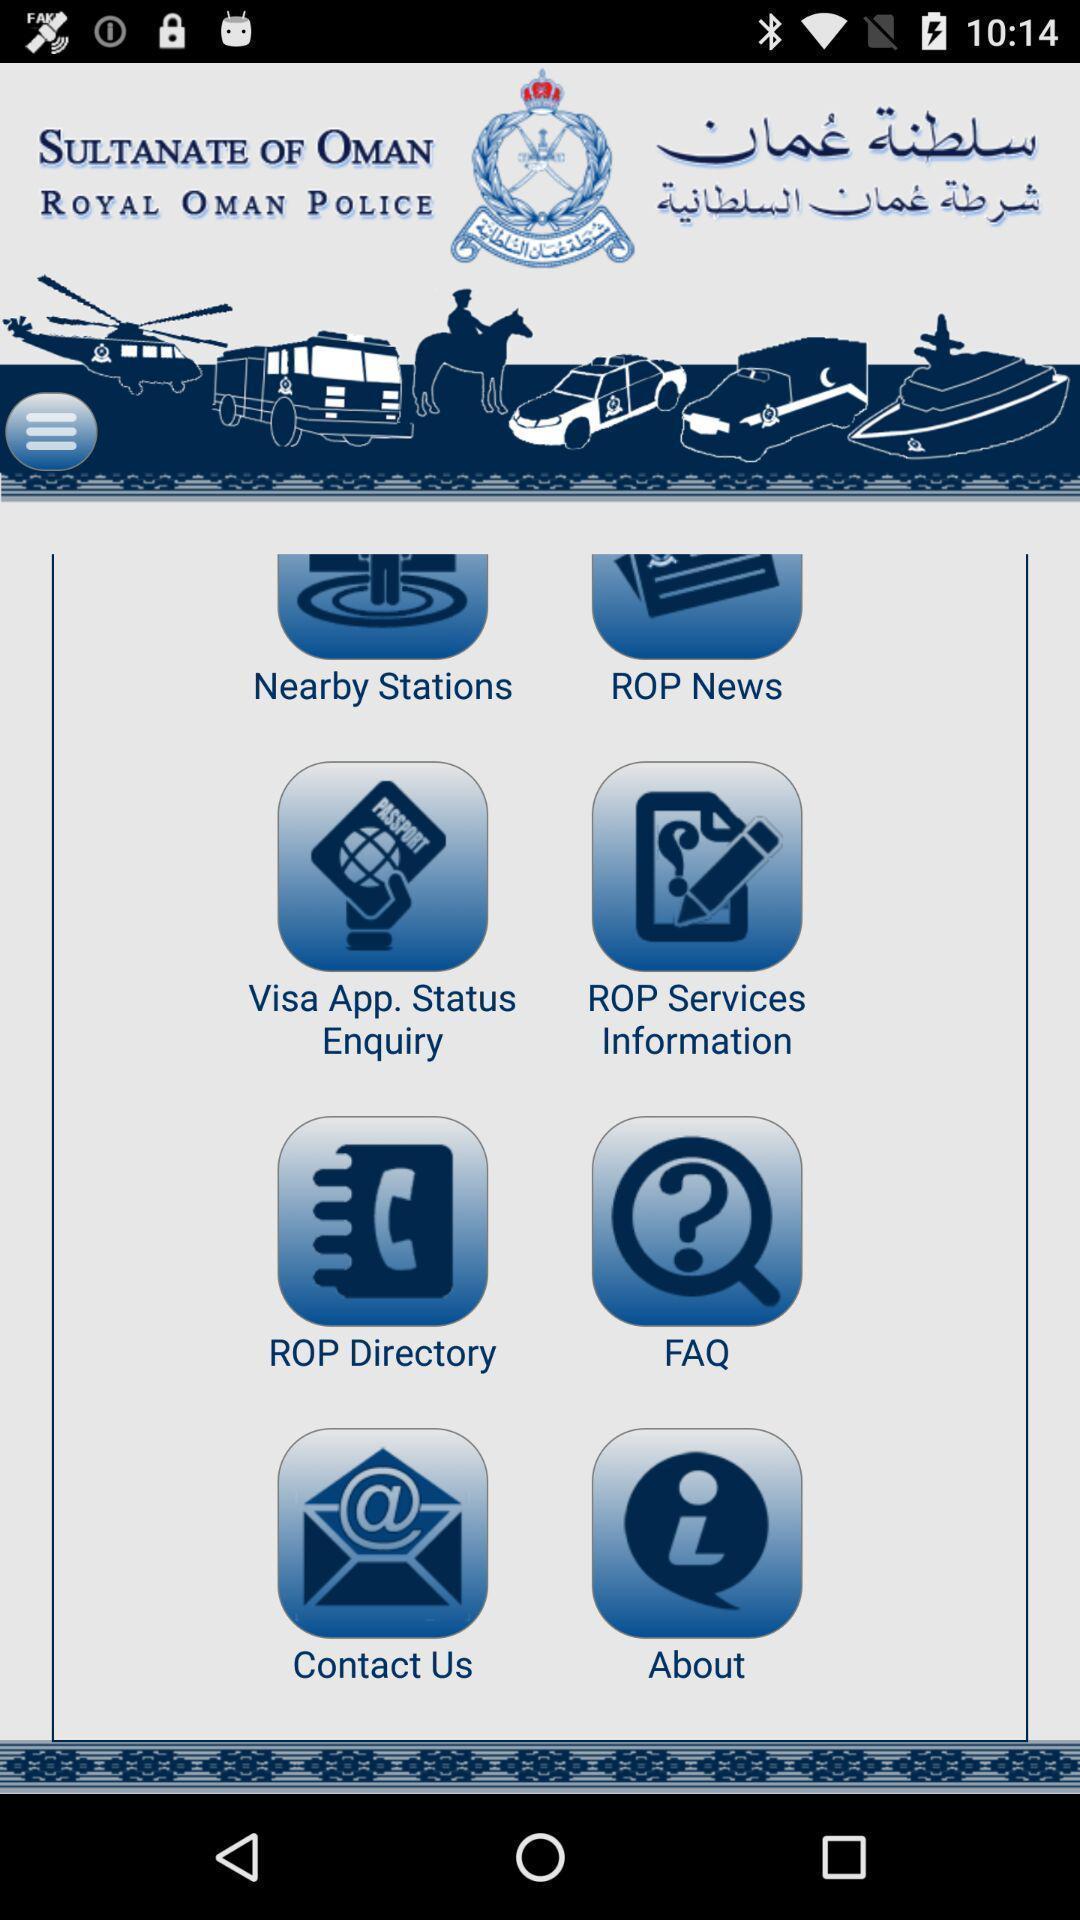Provide a textual representation of this image. Page displaying various categories. 